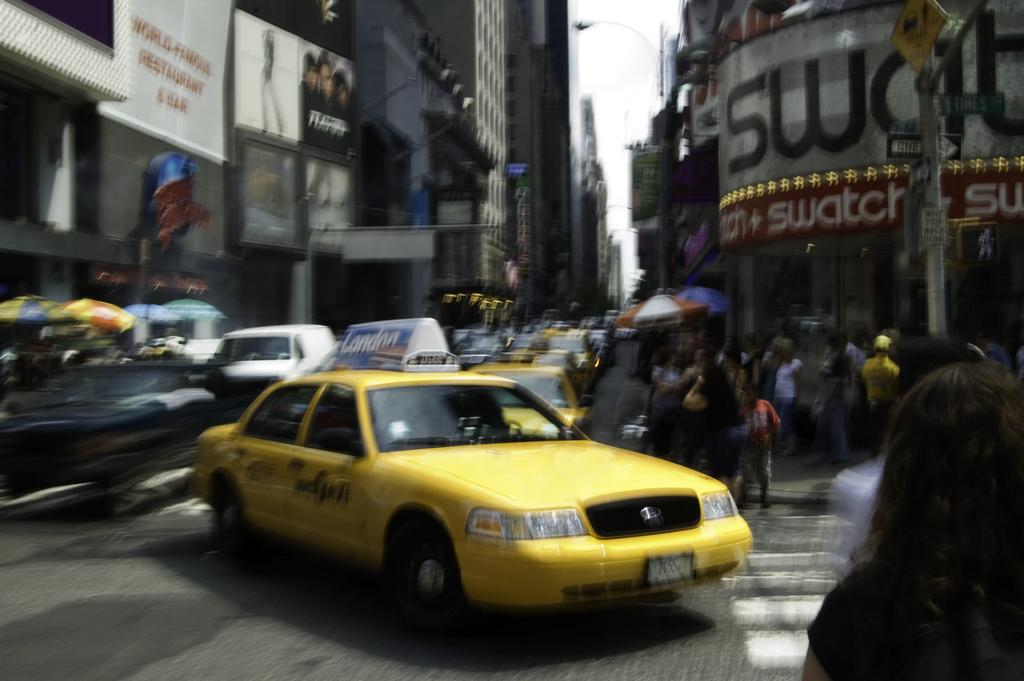What is the main feature of the image? There is a road in the image. What is happening on the road? There are cars on the road. Are there any people in the image? Yes, there are people standing in the image. What else can be seen in the image besides the road and people? There is a pole and buildings visible in the image. What type of bait is being used by the people in the image? There is no bait present in the image; it features a road, cars, people, a pole, and buildings. What shape is the hat worn by the person in the image? There is no hat present in the image; the people are standing without any headwear. 